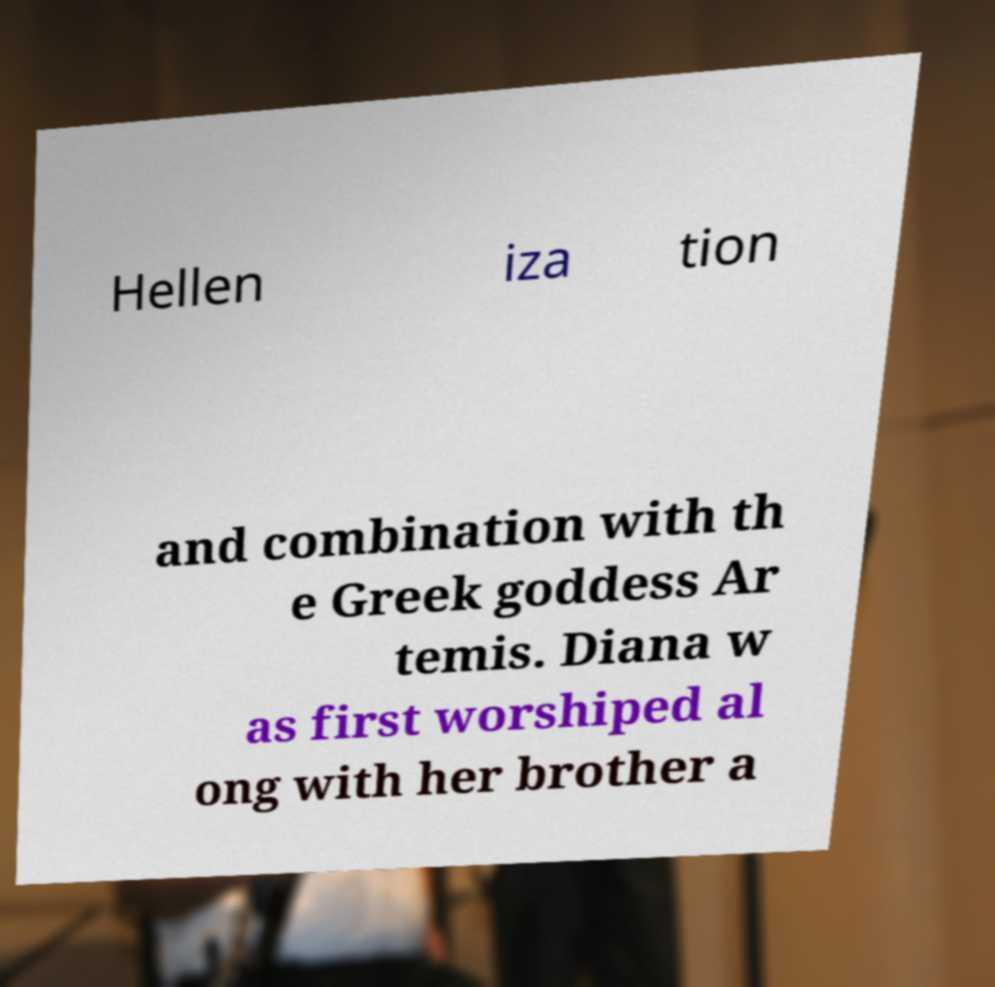Can you read and provide the text displayed in the image?This photo seems to have some interesting text. Can you extract and type it out for me? Hellen iza tion and combination with th e Greek goddess Ar temis. Diana w as first worshiped al ong with her brother a 